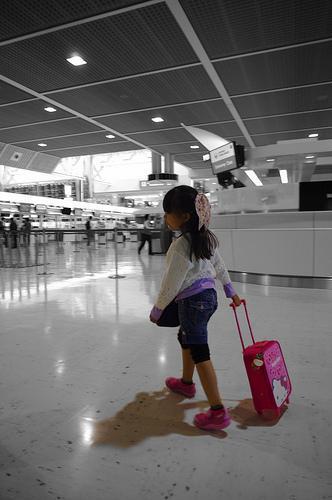How many girls are there?
Give a very brief answer. 1. 